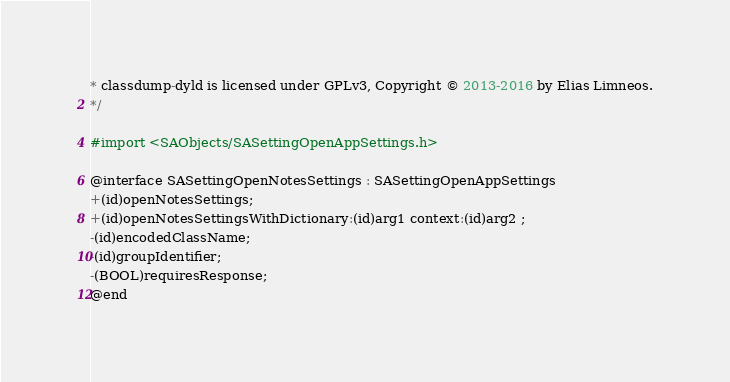Convert code to text. <code><loc_0><loc_0><loc_500><loc_500><_C_>* classdump-dyld is licensed under GPLv3, Copyright © 2013-2016 by Elias Limneos.
*/

#import <SAObjects/SASettingOpenAppSettings.h>

@interface SASettingOpenNotesSettings : SASettingOpenAppSettings
+(id)openNotesSettings;
+(id)openNotesSettingsWithDictionary:(id)arg1 context:(id)arg2 ;
-(id)encodedClassName;
-(id)groupIdentifier;
-(BOOL)requiresResponse;
@end

</code> 